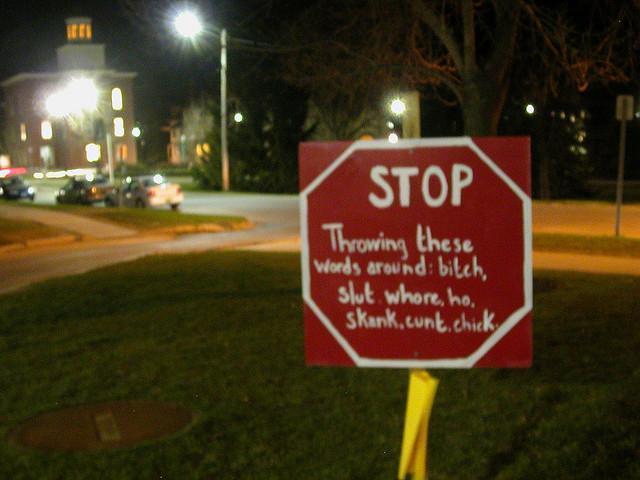How many airplanes are present?
Give a very brief answer. 0. 